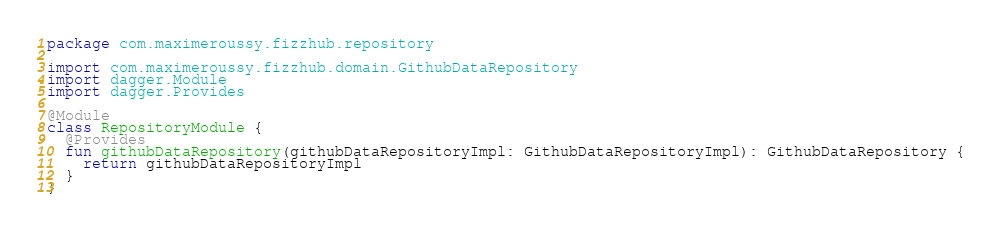<code> <loc_0><loc_0><loc_500><loc_500><_Kotlin_>package com.maximeroussy.fizzhub.repository

import com.maximeroussy.fizzhub.domain.GithubDataRepository
import dagger.Module
import dagger.Provides

@Module
class RepositoryModule {
  @Provides
  fun githubDataRepository(githubDataRepositoryImpl: GithubDataRepositoryImpl): GithubDataRepository {
    return githubDataRepositoryImpl
  }
}
</code> 